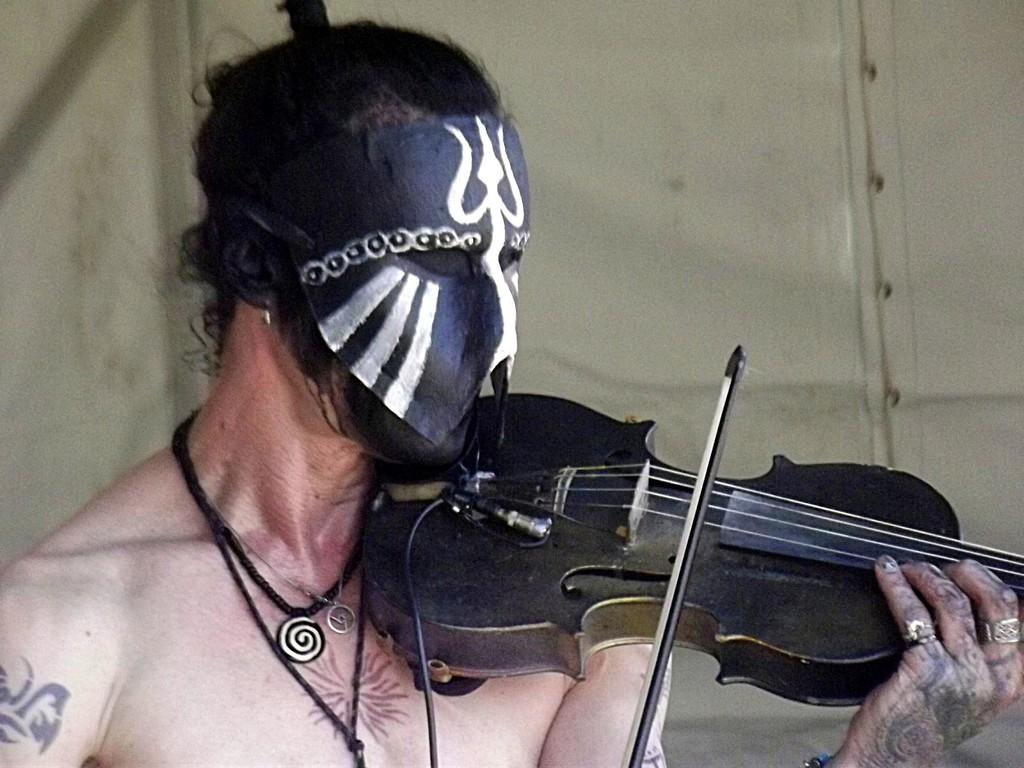What is the main subject of the image? There is a person in the image. What is the person wearing? The person is wearing a mask. What is the person doing in the image? The person is playing the violin. How does the person distribute the feast in the image? There is no feast present in the image, and the person is not distributing anything. 